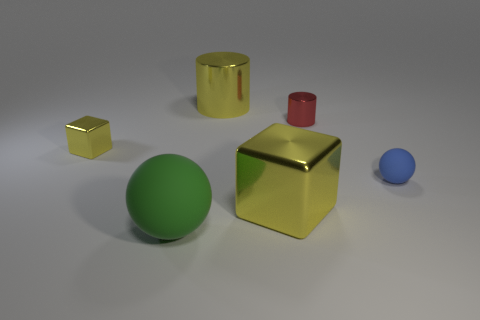Is there a pattern or theme to the colors of the objects? There doesn't appear to be a specific pattern, but the image features primary colors such as blue and red, as well as secondary color green, and neutral colors like gold and silver. Do the objects have textures? The objects have smooth surfaces reflective of materials like gold and what seems to be plastic or metal. 